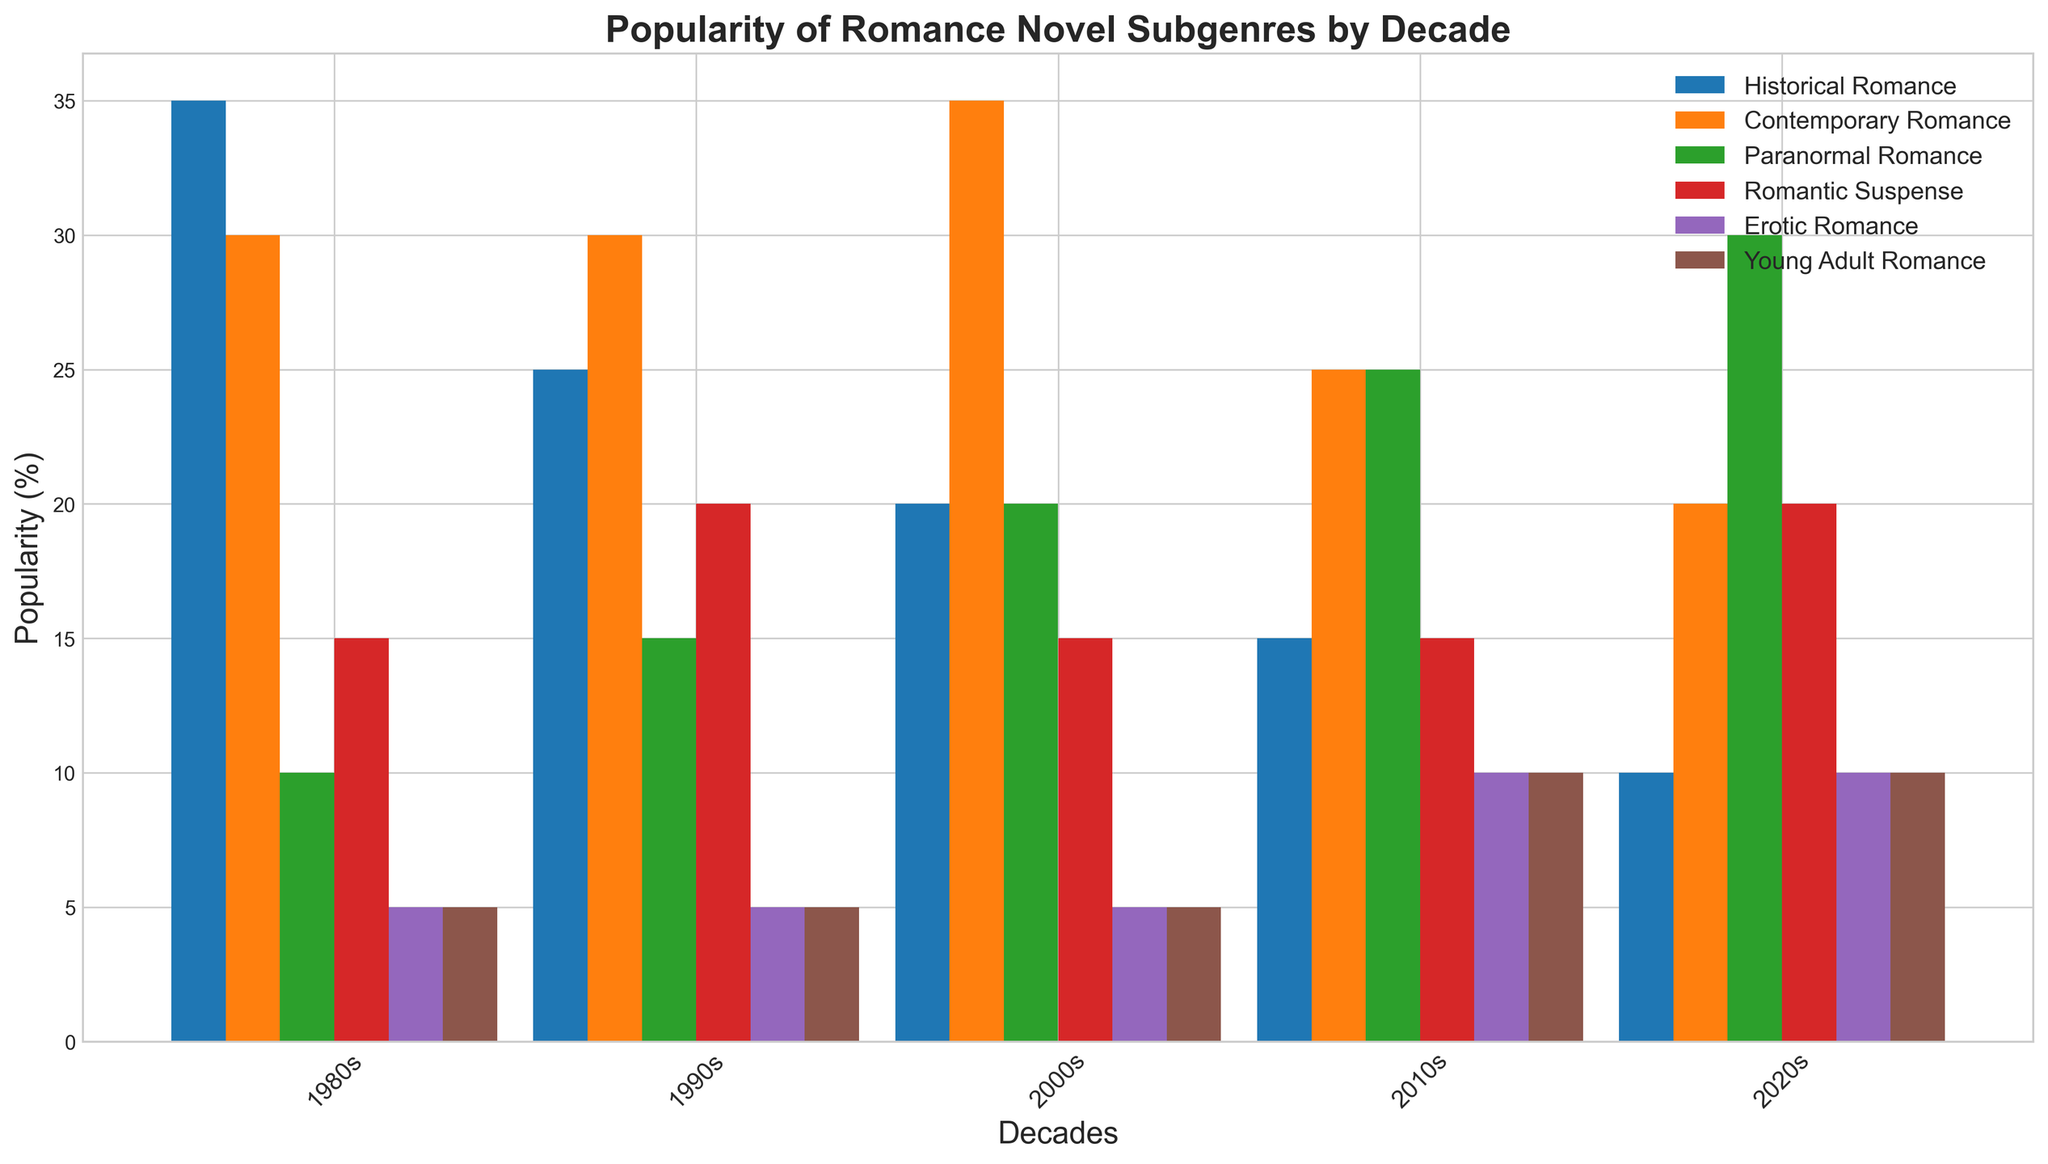What is the subgenre with the highest popularity in the 1980s? To find the most popular subgenre in the 1980s, look at the height of the bars for that decade. The "Historical Romance" bar is the tallest in the 1980s.
Answer: Historical Romance Which decade had the highest popularity for "Paranormal Romance"? Compare the heights of the bars for Paranormal Romance across all decades. The bar is tallest in the 2020s.
Answer: 2020s In the 2010s, which subgenres share the same popularity percentages? Observe the heights of the bars in the 2010s for equal values. Both "Romantic Suspense" and "Young Adult Romance" have bars at the same height.
Answer: Romantic Suspense, Young Adult Romance How has the popularity of "Historical Romance" changed over the decades? Notice the heights of the "Historical Romance" bars from the 1980s to the 2020s. The height consistently decreases each decade.
Answer: Decreased Which subgenre showed an increasing trend in popularity from the 1980s to the 2020s? Compare the heights of the bars for all subgenres across the decades. "Paranormal Romance" shows a consistent increase in height.
Answer: Paranormal Romance What was the combined popularity of "Erotic Romance" and "Young Adult Romance" in the 2010s? Check the individual heights of the "Erotic Romance" and "Young Adult Romance" bars in the 2010s and sum them. Both were at 10, so 10 + 10 = 20%.
Answer: 20% Which subgenre was more popular in the 1990s: "Romantic Suspense" or "Paranormal Romance"? Compare the heights of the bars for "Romantic Suspense" and "Paranormal Romance" in the 1990s. "Romantic Suspense" is taller.
Answer: Romantic Suspense During which time period did "Contemporary Romance" achieve its highest popularity? Compare the heights of the "Contemporary Romance" bars across all decades. The highest bar is in the 2000s.
Answer: 2000s 